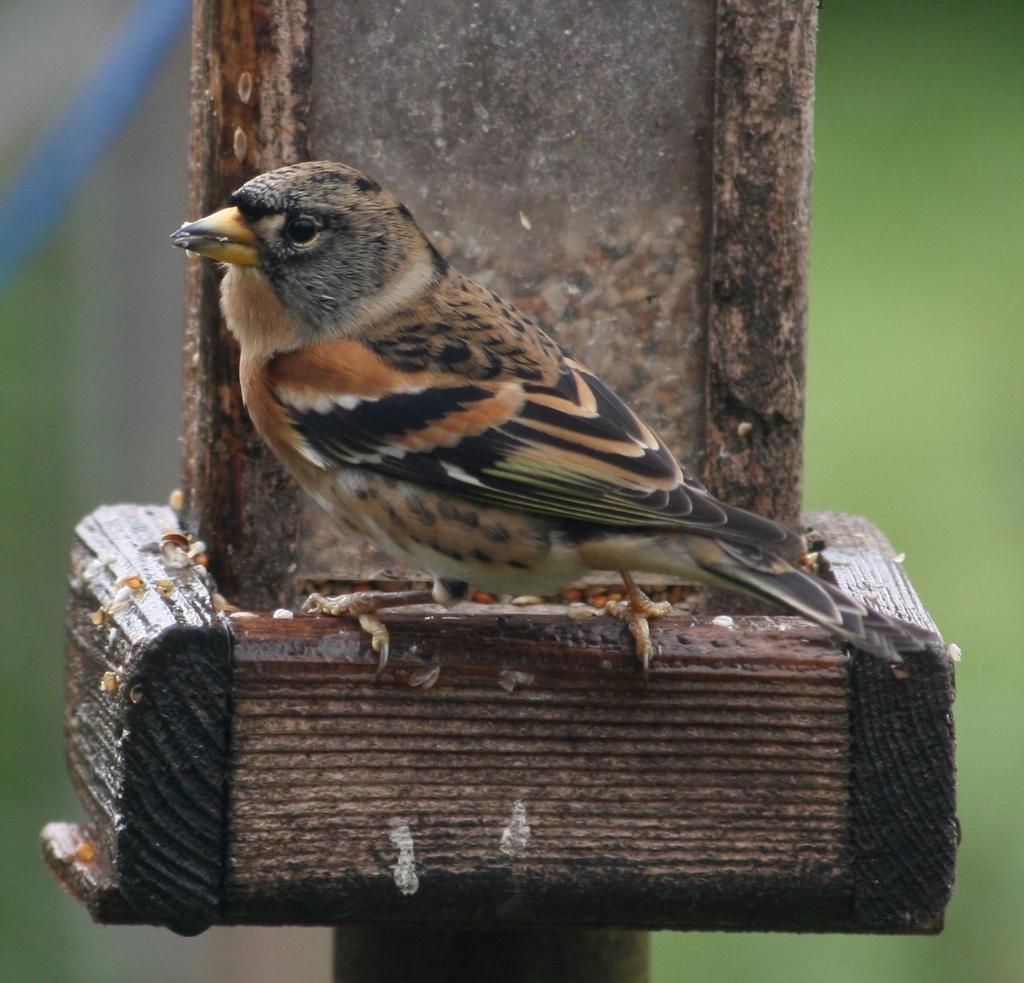How would you summarize this image in a sentence or two? In this image there is a bird on the wooden object. And the background is blurred. 